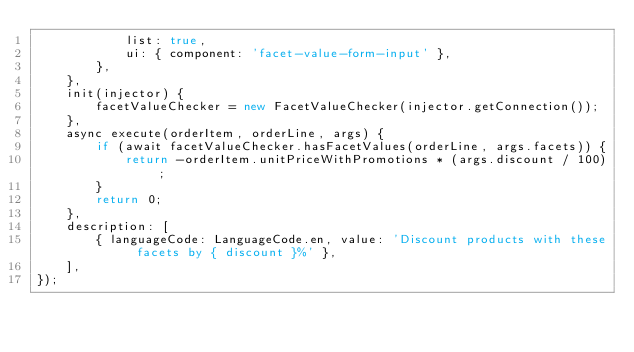Convert code to text. <code><loc_0><loc_0><loc_500><loc_500><_TypeScript_>            list: true,
            ui: { component: 'facet-value-form-input' },
        },
    },
    init(injector) {
        facetValueChecker = new FacetValueChecker(injector.getConnection());
    },
    async execute(orderItem, orderLine, args) {
        if (await facetValueChecker.hasFacetValues(orderLine, args.facets)) {
            return -orderItem.unitPriceWithPromotions * (args.discount / 100);
        }
        return 0;
    },
    description: [
        { languageCode: LanguageCode.en, value: 'Discount products with these facets by { discount }%' },
    ],
});
</code> 